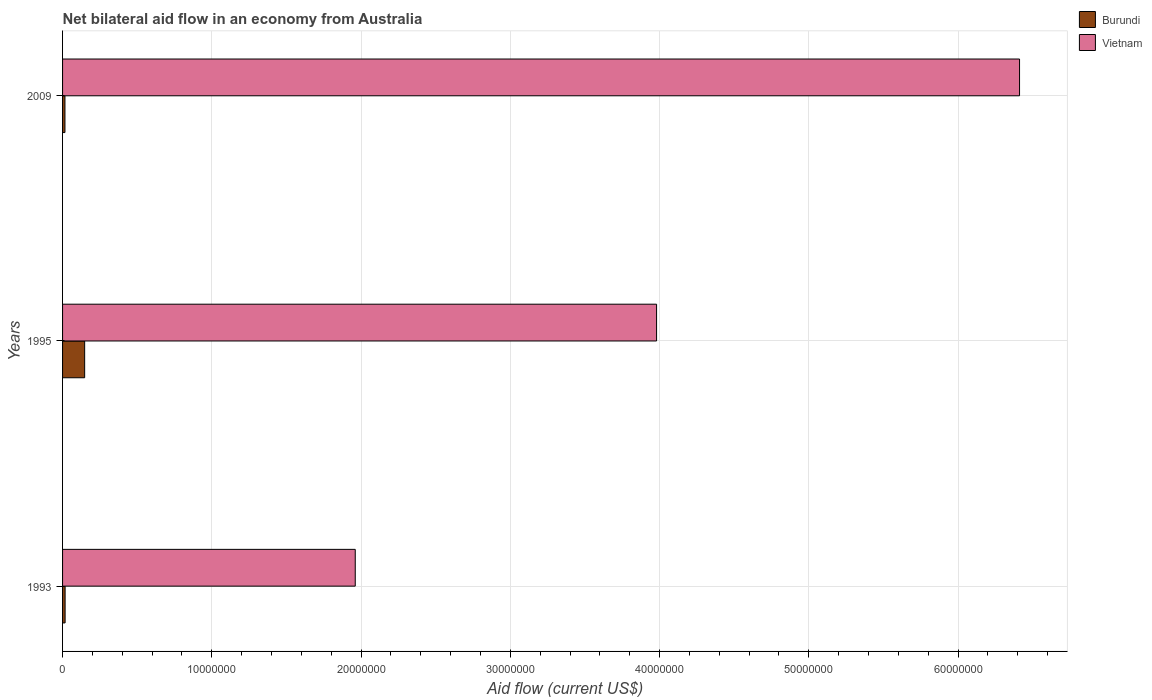Are the number of bars per tick equal to the number of legend labels?
Make the answer very short. Yes. Are the number of bars on each tick of the Y-axis equal?
Give a very brief answer. Yes. What is the label of the 2nd group of bars from the top?
Offer a very short reply. 1995. In how many cases, is the number of bars for a given year not equal to the number of legend labels?
Provide a succinct answer. 0. What is the net bilateral aid flow in Vietnam in 1995?
Your answer should be very brief. 3.98e+07. Across all years, what is the maximum net bilateral aid flow in Vietnam?
Ensure brevity in your answer.  6.41e+07. Across all years, what is the minimum net bilateral aid flow in Vietnam?
Give a very brief answer. 1.96e+07. What is the total net bilateral aid flow in Burundi in the graph?
Keep it short and to the point. 1.81e+06. What is the difference between the net bilateral aid flow in Burundi in 2009 and the net bilateral aid flow in Vietnam in 1995?
Your response must be concise. -3.96e+07. What is the average net bilateral aid flow in Burundi per year?
Provide a short and direct response. 6.03e+05. In the year 2009, what is the difference between the net bilateral aid flow in Vietnam and net bilateral aid flow in Burundi?
Provide a short and direct response. 6.40e+07. In how many years, is the net bilateral aid flow in Burundi greater than 24000000 US$?
Ensure brevity in your answer.  0. What is the ratio of the net bilateral aid flow in Vietnam in 1995 to that in 2009?
Give a very brief answer. 0.62. Is the net bilateral aid flow in Burundi in 1993 less than that in 2009?
Provide a short and direct response. No. What is the difference between the highest and the second highest net bilateral aid flow in Burundi?
Your answer should be very brief. 1.31e+06. What is the difference between the highest and the lowest net bilateral aid flow in Burundi?
Your response must be concise. 1.32e+06. Is the sum of the net bilateral aid flow in Burundi in 1993 and 2009 greater than the maximum net bilateral aid flow in Vietnam across all years?
Your answer should be very brief. No. What does the 2nd bar from the top in 1995 represents?
Your answer should be very brief. Burundi. What does the 2nd bar from the bottom in 1993 represents?
Provide a short and direct response. Vietnam. Are the values on the major ticks of X-axis written in scientific E-notation?
Your answer should be compact. No. What is the title of the graph?
Your answer should be compact. Net bilateral aid flow in an economy from Australia. Does "Upper middle income" appear as one of the legend labels in the graph?
Your response must be concise. No. What is the label or title of the X-axis?
Offer a very short reply. Aid flow (current US$). What is the label or title of the Y-axis?
Make the answer very short. Years. What is the Aid flow (current US$) of Burundi in 1993?
Ensure brevity in your answer.  1.70e+05. What is the Aid flow (current US$) in Vietnam in 1993?
Provide a short and direct response. 1.96e+07. What is the Aid flow (current US$) in Burundi in 1995?
Offer a very short reply. 1.48e+06. What is the Aid flow (current US$) in Vietnam in 1995?
Your answer should be very brief. 3.98e+07. What is the Aid flow (current US$) of Vietnam in 2009?
Provide a short and direct response. 6.41e+07. Across all years, what is the maximum Aid flow (current US$) in Burundi?
Your response must be concise. 1.48e+06. Across all years, what is the maximum Aid flow (current US$) in Vietnam?
Provide a succinct answer. 6.41e+07. Across all years, what is the minimum Aid flow (current US$) of Vietnam?
Your response must be concise. 1.96e+07. What is the total Aid flow (current US$) in Burundi in the graph?
Provide a succinct answer. 1.81e+06. What is the total Aid flow (current US$) in Vietnam in the graph?
Make the answer very short. 1.24e+08. What is the difference between the Aid flow (current US$) of Burundi in 1993 and that in 1995?
Ensure brevity in your answer.  -1.31e+06. What is the difference between the Aid flow (current US$) of Vietnam in 1993 and that in 1995?
Your answer should be very brief. -2.02e+07. What is the difference between the Aid flow (current US$) in Vietnam in 1993 and that in 2009?
Provide a short and direct response. -4.45e+07. What is the difference between the Aid flow (current US$) of Burundi in 1995 and that in 2009?
Make the answer very short. 1.32e+06. What is the difference between the Aid flow (current US$) of Vietnam in 1995 and that in 2009?
Give a very brief answer. -2.43e+07. What is the difference between the Aid flow (current US$) of Burundi in 1993 and the Aid flow (current US$) of Vietnam in 1995?
Offer a very short reply. -3.96e+07. What is the difference between the Aid flow (current US$) of Burundi in 1993 and the Aid flow (current US$) of Vietnam in 2009?
Ensure brevity in your answer.  -6.40e+07. What is the difference between the Aid flow (current US$) in Burundi in 1995 and the Aid flow (current US$) in Vietnam in 2009?
Your response must be concise. -6.26e+07. What is the average Aid flow (current US$) in Burundi per year?
Your answer should be compact. 6.03e+05. What is the average Aid flow (current US$) in Vietnam per year?
Give a very brief answer. 4.12e+07. In the year 1993, what is the difference between the Aid flow (current US$) in Burundi and Aid flow (current US$) in Vietnam?
Your response must be concise. -1.94e+07. In the year 1995, what is the difference between the Aid flow (current US$) in Burundi and Aid flow (current US$) in Vietnam?
Give a very brief answer. -3.83e+07. In the year 2009, what is the difference between the Aid flow (current US$) of Burundi and Aid flow (current US$) of Vietnam?
Your answer should be compact. -6.40e+07. What is the ratio of the Aid flow (current US$) of Burundi in 1993 to that in 1995?
Your response must be concise. 0.11. What is the ratio of the Aid flow (current US$) of Vietnam in 1993 to that in 1995?
Provide a short and direct response. 0.49. What is the ratio of the Aid flow (current US$) of Vietnam in 1993 to that in 2009?
Keep it short and to the point. 0.31. What is the ratio of the Aid flow (current US$) of Burundi in 1995 to that in 2009?
Your answer should be compact. 9.25. What is the ratio of the Aid flow (current US$) in Vietnam in 1995 to that in 2009?
Provide a succinct answer. 0.62. What is the difference between the highest and the second highest Aid flow (current US$) in Burundi?
Make the answer very short. 1.31e+06. What is the difference between the highest and the second highest Aid flow (current US$) of Vietnam?
Your answer should be compact. 2.43e+07. What is the difference between the highest and the lowest Aid flow (current US$) in Burundi?
Your response must be concise. 1.32e+06. What is the difference between the highest and the lowest Aid flow (current US$) in Vietnam?
Offer a very short reply. 4.45e+07. 